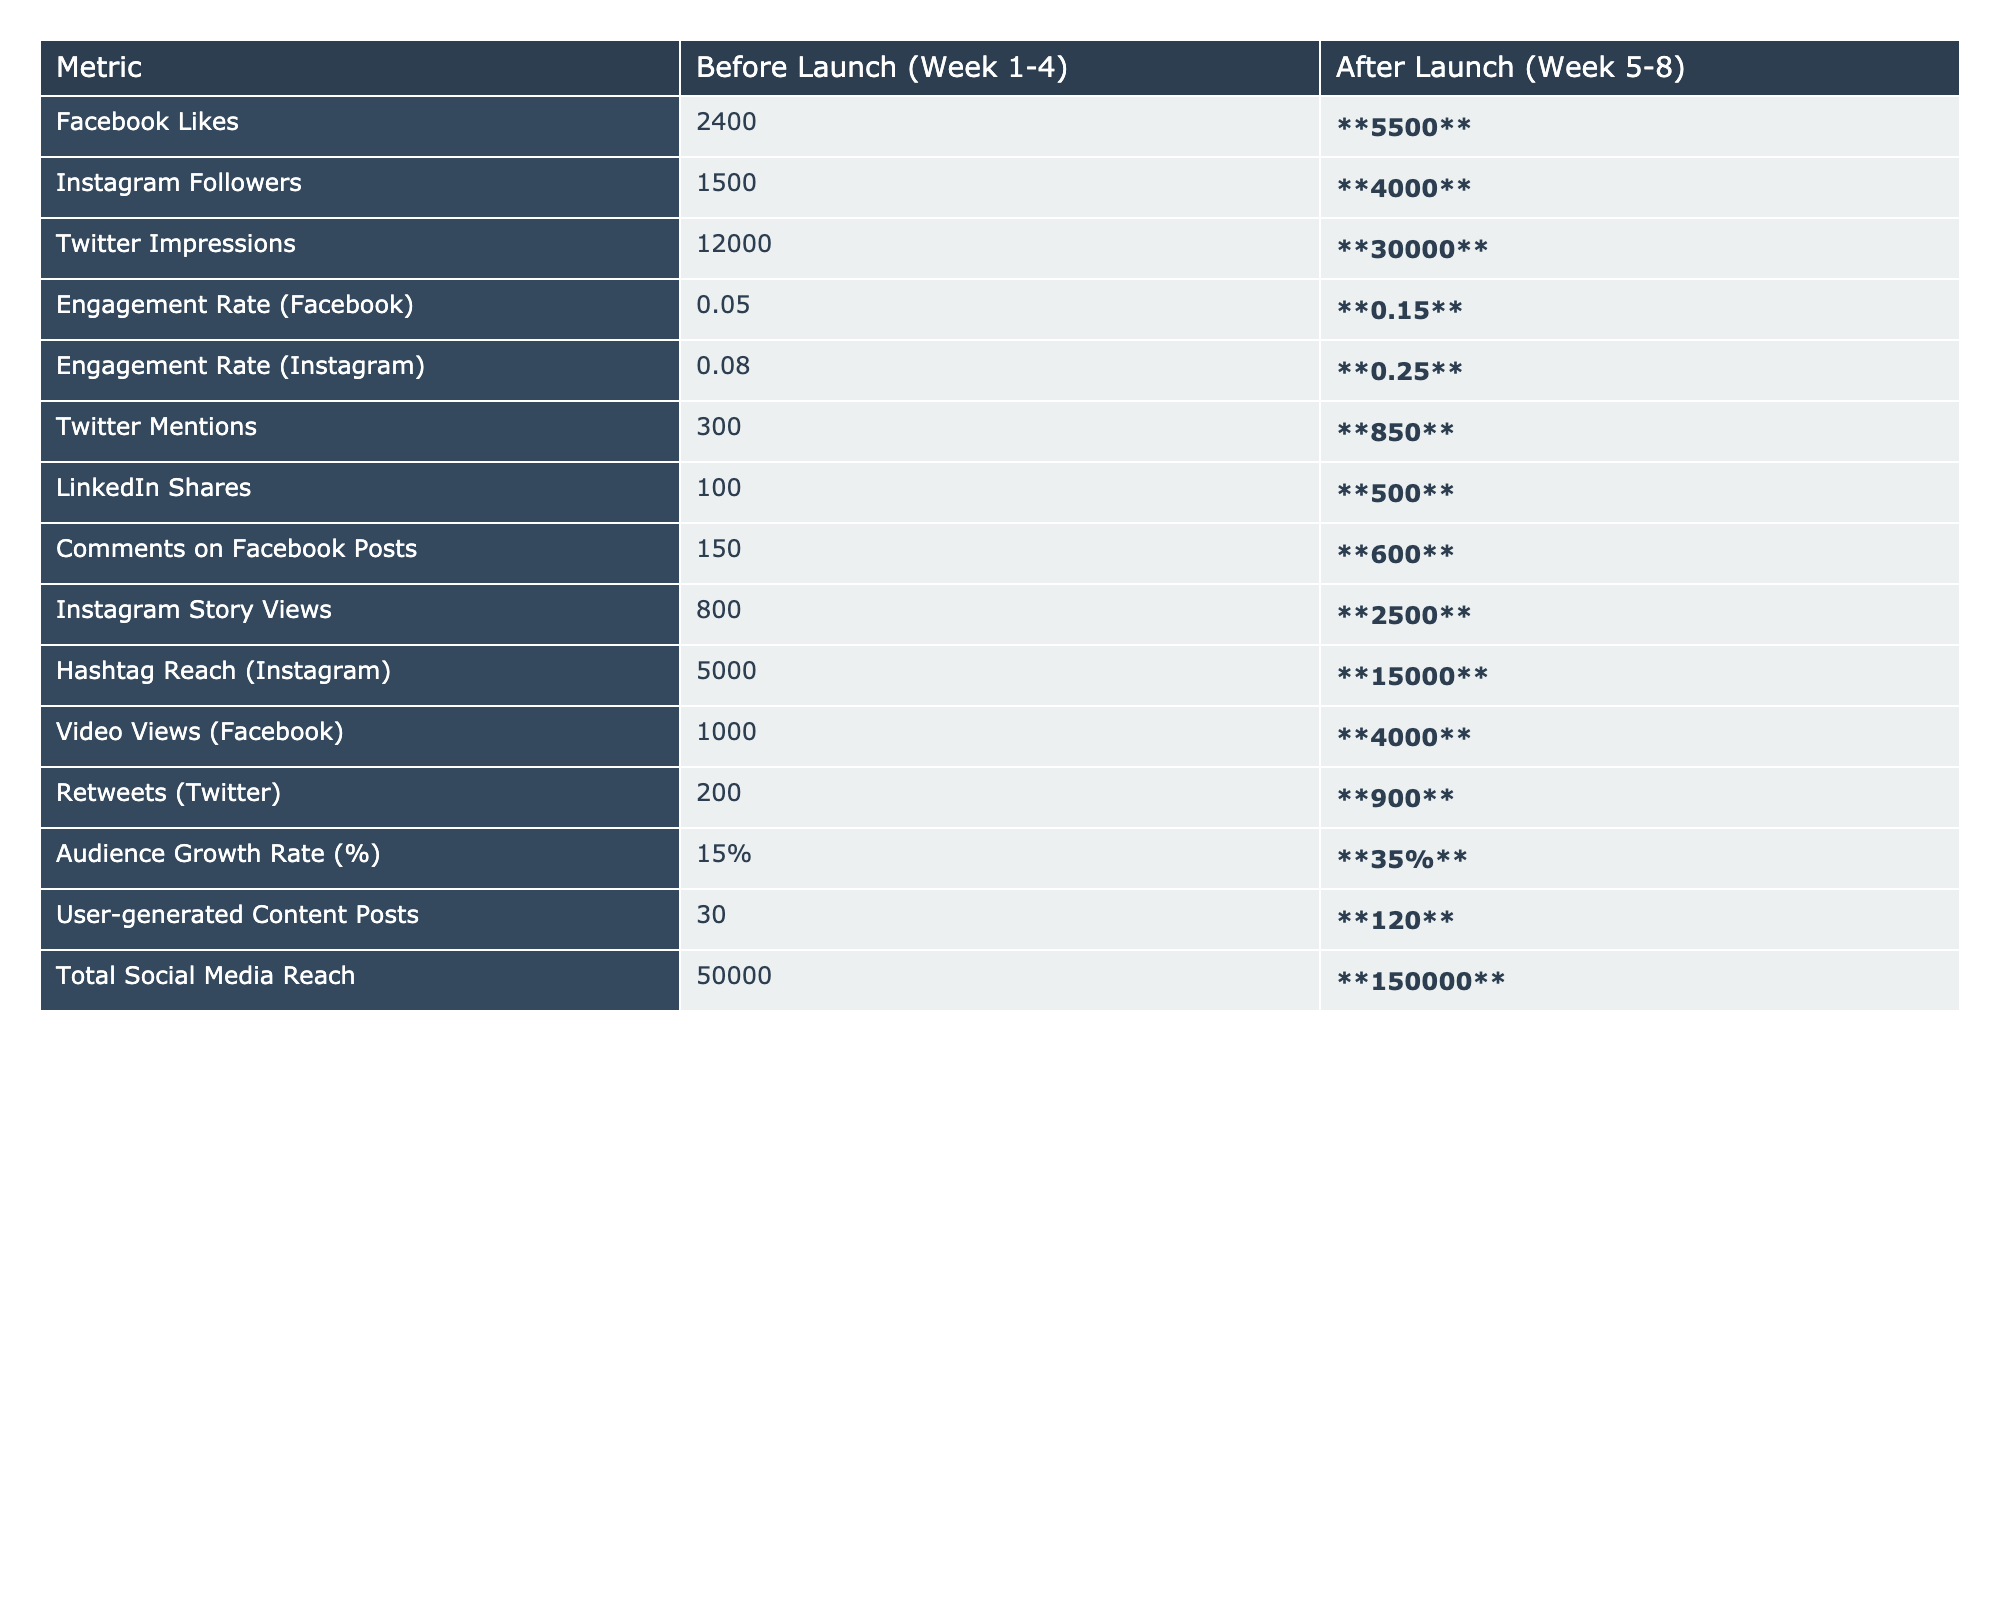What is the increase in Facebook Likes after the product launch? Before launch, there were 2400 Facebook Likes, and after launch, there are 5500 Likes. The increase can be calculated by subtracting the before value from the after value: 5500 - 2400 = 3100.
Answer: 3100 What is the engagement rate for Instagram after the launch? The engagement rate for Instagram after the launch is bolded in the table as 0.25.
Answer: 0.25 How many more Twitter impressions were recorded after the launch compared to before? Before the launch, there were 12000 Twitter impressions, and after the launch, there are 30000 impressions. The increase is calculated as 30000 - 12000 = 18000.
Answer: 18000 Did the audience growth rate increase by more than 15% after the launch? The audience growth rate before the launch was 15%, and after the launch, it increased to 35%. Therefore, it increased by 20% (35% - 15%), which is more than 15%.
Answer: Yes What is the total increase in the number of comments on Facebook posts before and after the launch? Before launch, there were 150 comments on Facebook posts, and after launch, there were 600 comments. The total increase is 600 - 150 = 450 comments.
Answer: 450 What was the total social media reach before the launch? The total social media reach before the launch is listed in the table as 50000.
Answer: 50000 Calculate the average number of Instagram followers before and after the launch. Before the launch, there were 1500 Instagram followers, and after the launch, there were 4000 followers. The average is calculated by summing these values (1500 + 4000 = 5500) and dividing by 2, which results in 5500 / 2 = 2750.
Answer: 2750 How much did the number of user-generated content posts increase after the launch? Before the launch, there were 30 user-generated content posts, and after launch, there were 120 posts. The increase is calculated as 120 - 30 = 90 posts.
Answer: 90 Is the engagement rate on Facebook higher than that on Instagram after the launch? After the launch, the Facebook engagement rate is 0.15, and the Instagram engagement rate is 0.25. Since 0.15 is less than 0.25, the Facebook engagement rate is not higher than Instagram's after the launch.
Answer: No What percentage of the Twitter mentions increased after the launch? Before launch, there were 300 Twitter mentions and after launch there are 850 mentions. The increase is 850 - 300 = 550 mentions. To find the percentage increase: (550 / 300) * 100 = 183.33%.
Answer: 183.33% 